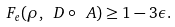<formula> <loc_0><loc_0><loc_500><loc_500>F _ { e } ( \rho , \ D \circ \ A ) \geq 1 - 3 \epsilon .</formula> 